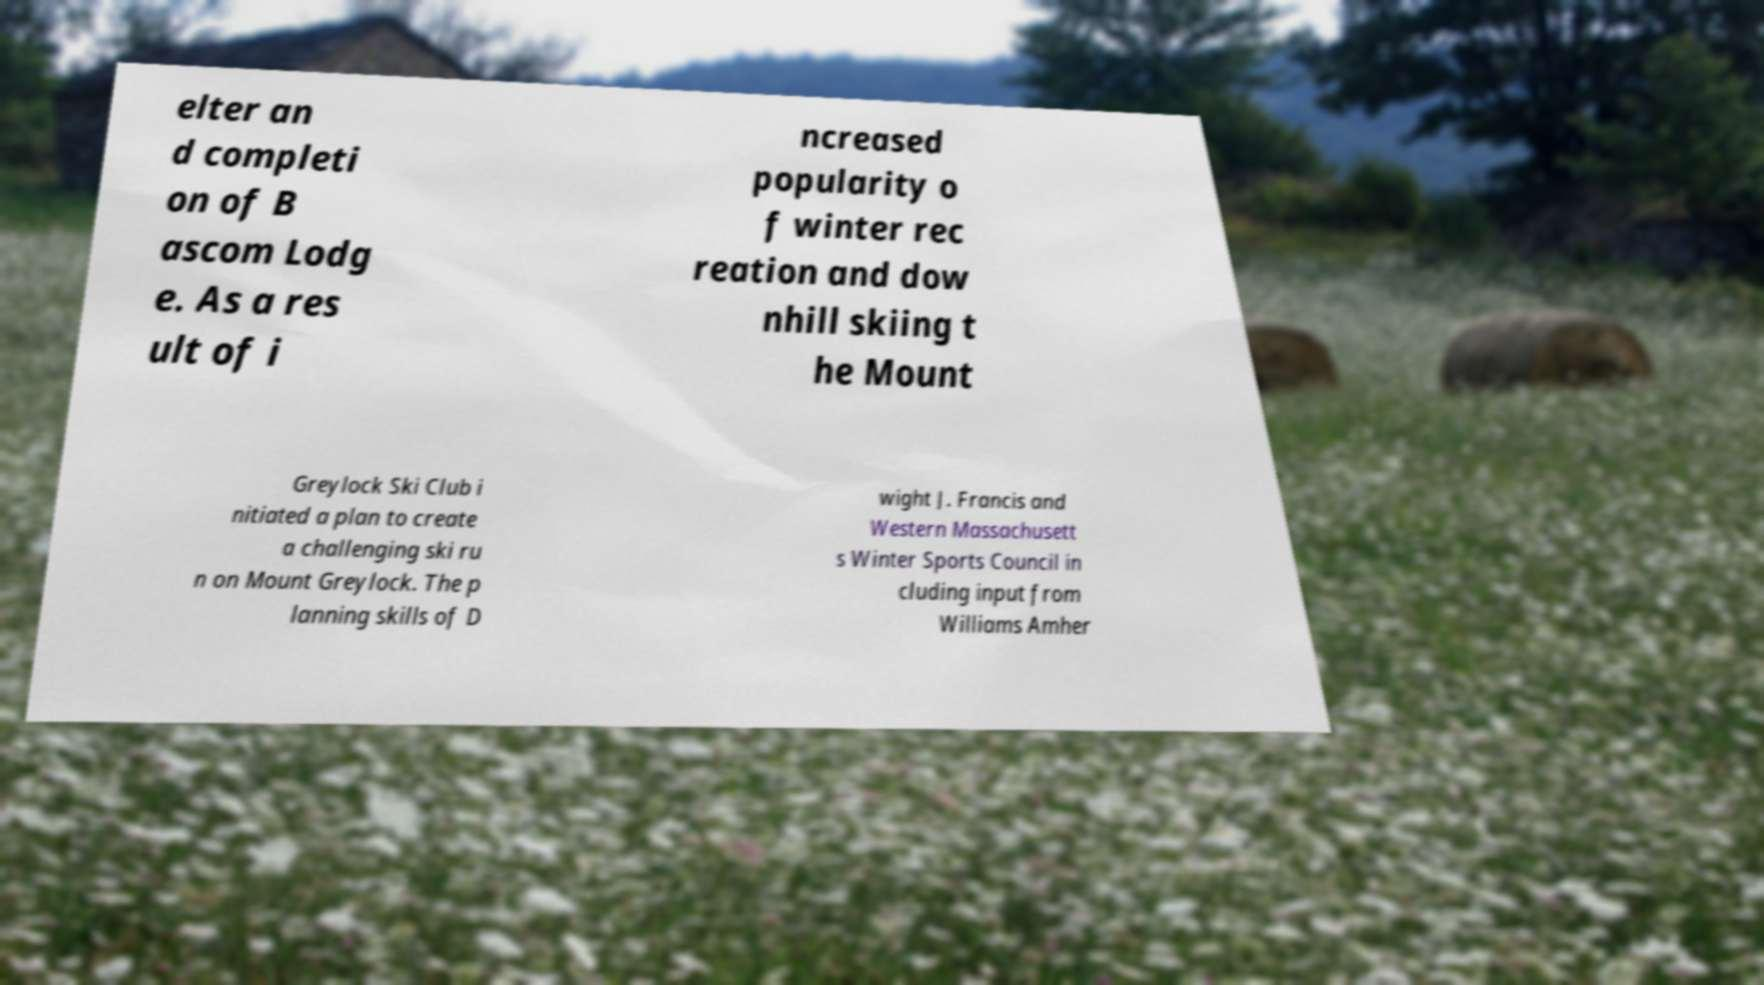There's text embedded in this image that I need extracted. Can you transcribe it verbatim? elter an d completi on of B ascom Lodg e. As a res ult of i ncreased popularity o f winter rec reation and dow nhill skiing t he Mount Greylock Ski Club i nitiated a plan to create a challenging ski ru n on Mount Greylock. The p lanning skills of D wight J. Francis and Western Massachusett s Winter Sports Council in cluding input from Williams Amher 